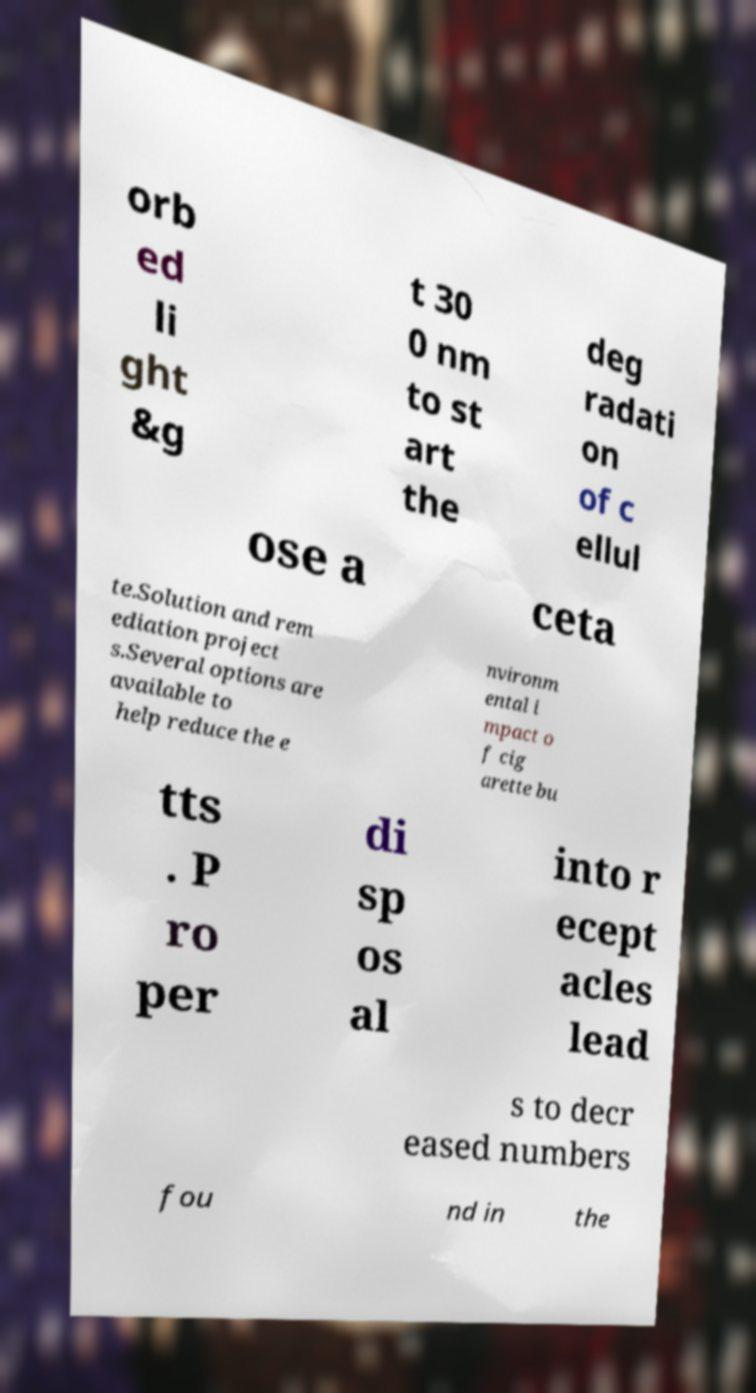Please read and relay the text visible in this image. What does it say? orb ed li ght &g t 30 0 nm to st art the deg radati on of c ellul ose a ceta te.Solution and rem ediation project s.Several options are available to help reduce the e nvironm ental i mpact o f cig arette bu tts . P ro per di sp os al into r ecept acles lead s to decr eased numbers fou nd in the 